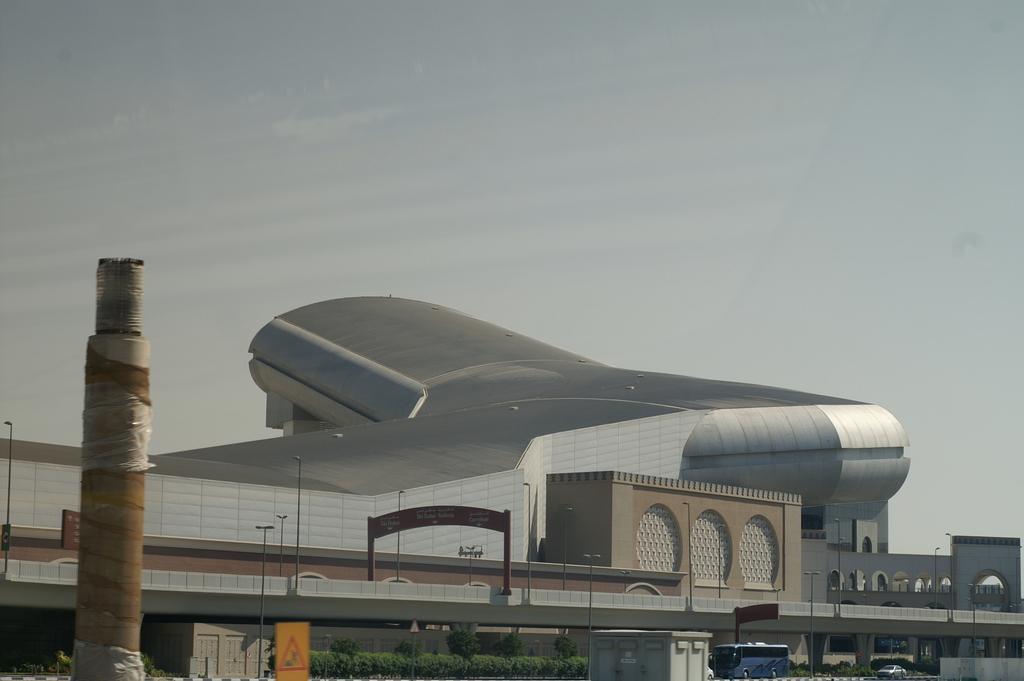Could you give a brief overview of what you see in this image? In this image at the bottom we can see vehicles on the road, plants, sign board, street lights and objects. In the background we can see an arch on the bridge, buildings, street lights and clouds in the sky. 